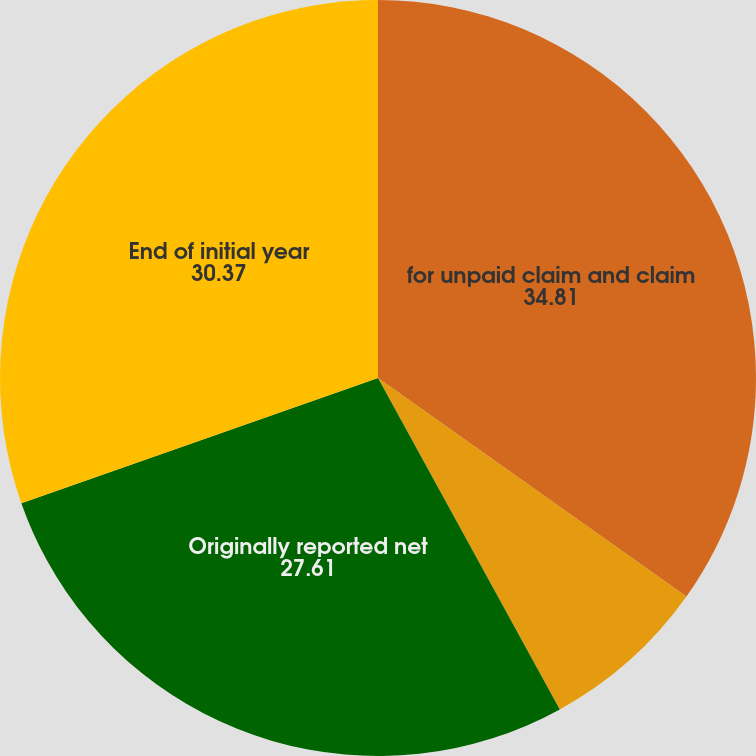Convert chart to OTSL. <chart><loc_0><loc_0><loc_500><loc_500><pie_chart><fcel>for unpaid claim and claim<fcel>Originally reported ceded<fcel>Originally reported net<fcel>End of initial year<nl><fcel>34.81%<fcel>7.2%<fcel>27.61%<fcel>30.37%<nl></chart> 